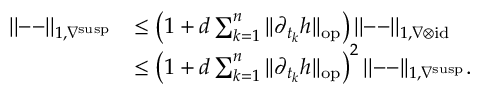Convert formula to latex. <formula><loc_0><loc_0><loc_500><loc_500>\begin{array} { r l } { | | - - | | _ { 1 , \nabla ^ { s u s p } } } & { \leq \left ( 1 + d \sum _ { k = 1 } ^ { n } | | \partial _ { t _ { k } } h | | _ { o p } \right ) | | - - | | _ { 1 , \nabla \otimes i d } } \\ & { \leq \left ( 1 + d \sum _ { k = 1 } ^ { n } | | \partial _ { t _ { k } } h | | _ { o p } \right ) ^ { 2 } | | - - | | _ { 1 , \nabla ^ { s u s p } } . } \end{array}</formula> 